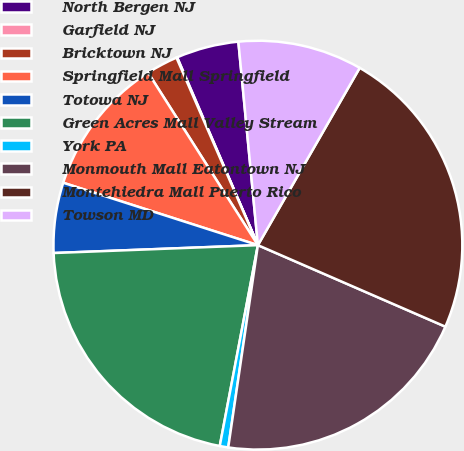<chart> <loc_0><loc_0><loc_500><loc_500><pie_chart><fcel>North Bergen NJ<fcel>Garfield NJ<fcel>Bricktown NJ<fcel>Springfield Mall Springfield<fcel>Totowa NJ<fcel>Green Acres Mall Valley Stream<fcel>York PA<fcel>Monmouth Mall Eatontown NJ<fcel>Montehiedra Mall Puerto Rico<fcel>Towson MD<nl><fcel>4.94%<fcel>0.06%<fcel>2.5%<fcel>11.04%<fcel>5.55%<fcel>21.4%<fcel>0.67%<fcel>20.79%<fcel>23.23%<fcel>9.82%<nl></chart> 